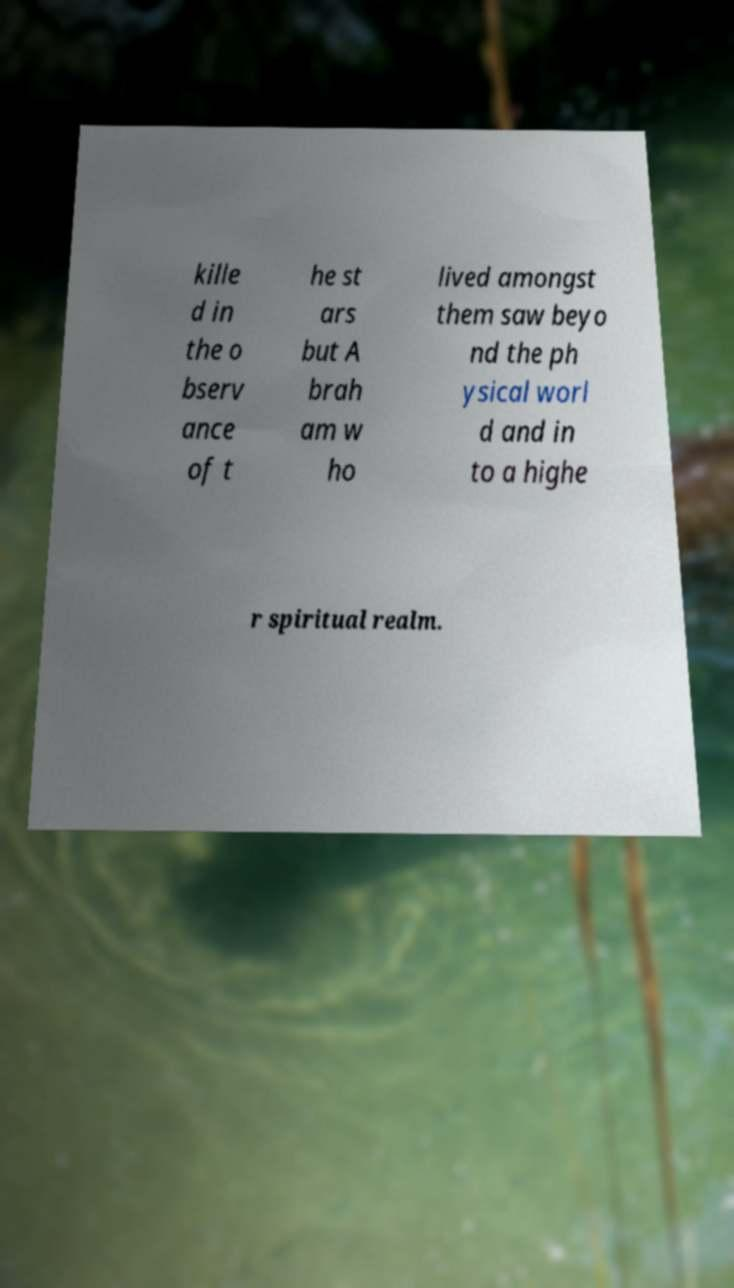I need the written content from this picture converted into text. Can you do that? kille d in the o bserv ance of t he st ars but A brah am w ho lived amongst them saw beyo nd the ph ysical worl d and in to a highe r spiritual realm. 